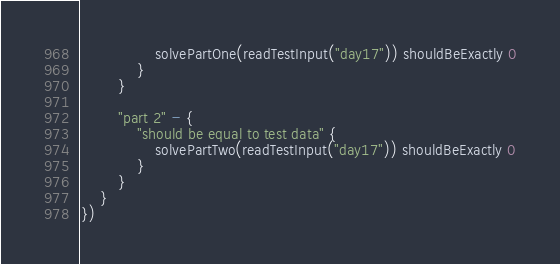<code> <loc_0><loc_0><loc_500><loc_500><_Kotlin_>                solvePartOne(readTestInput("day17")) shouldBeExactly 0
            }
        }

        "part 2" - {
            "should be equal to test data" {
                solvePartTwo(readTestInput("day17")) shouldBeExactly 0
            }
        }
    }
})
</code> 